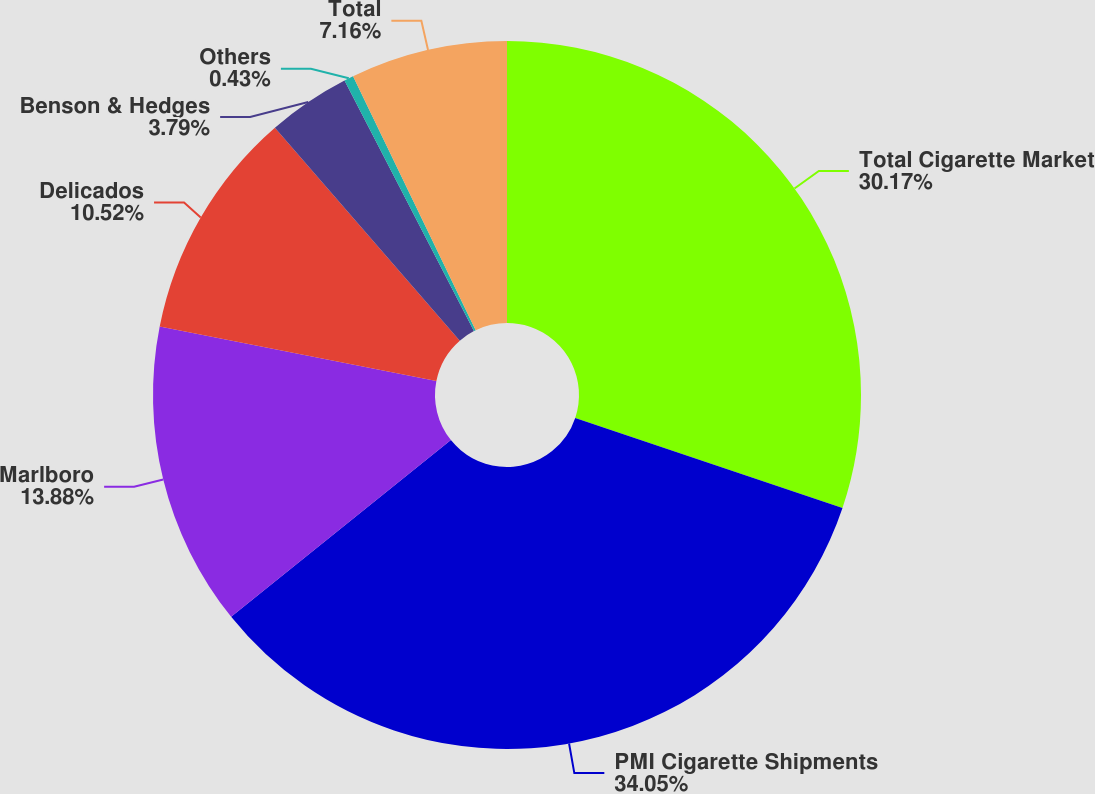<chart> <loc_0><loc_0><loc_500><loc_500><pie_chart><fcel>Total Cigarette Market<fcel>PMI Cigarette Shipments<fcel>Marlboro<fcel>Delicados<fcel>Benson & Hedges<fcel>Others<fcel>Total<nl><fcel>30.17%<fcel>34.05%<fcel>13.88%<fcel>10.52%<fcel>3.79%<fcel>0.43%<fcel>7.16%<nl></chart> 